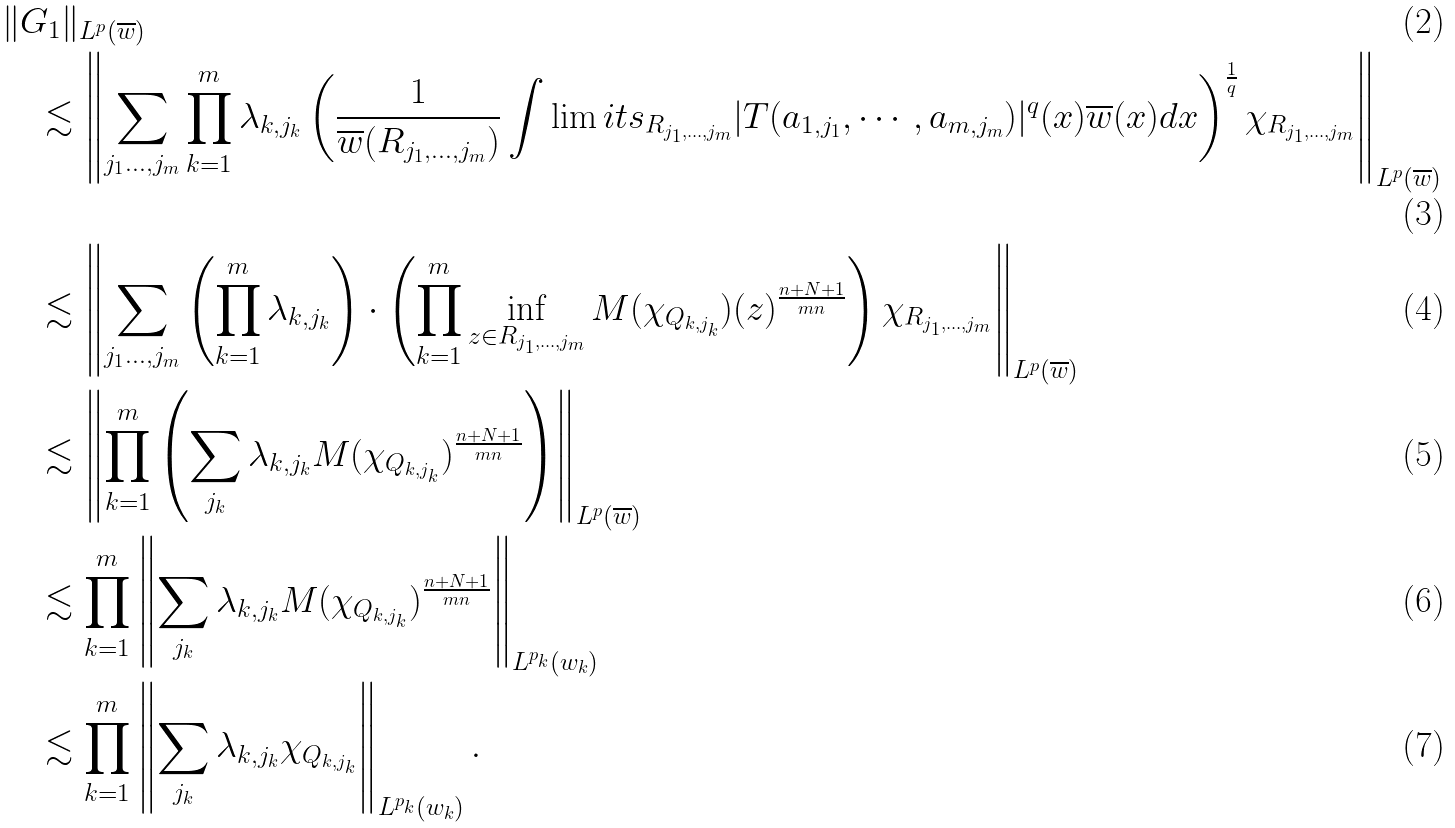<formula> <loc_0><loc_0><loc_500><loc_500>& \| G _ { 1 } \| _ { L ^ { p } ( \overline { w } ) } \\ & \quad \lesssim \left \| \sum _ { j _ { 1 } \dots , j _ { m } } \prod _ { k = 1 } ^ { m } { \lambda _ { k , j _ { k } } } \left ( \frac { 1 } { \overline { w } ( R _ { j _ { 1 } , \dots , j _ { m } } ) } \int \lim i t s _ { R _ { j _ { 1 } , \dots , j _ { m } } } | T ( a _ { 1 , j _ { 1 } } , \cdots , a _ { m , j _ { m } } ) | ^ { q } ( x ) \overline { w } ( x ) d x \right ) ^ { \frac { 1 } { q } } \chi _ { R _ { j _ { 1 } , \dots , j _ { m } } } \right \| _ { L ^ { p } ( \overline { w } ) } \\ & \quad \lesssim \left \| \sum _ { j _ { 1 } \dots , j _ { m } } \left ( \prod _ { k = 1 } ^ { m } { \lambda _ { k , j _ { k } } } \right ) \cdot \left ( \prod _ { k = 1 } ^ { m } \inf _ { z \in R _ { j _ { 1 } , \dots , j _ { m } } } M ( \chi _ { Q _ { k , j _ { k } } } ) ( z ) ^ { \frac { n + N + 1 } { m n } } \right ) \chi _ { R _ { j _ { 1 } , \dots , j _ { m } } } \right \| _ { L ^ { p } ( \overline { w } ) } \\ & \quad \lesssim \left \| \prod _ { k = 1 } ^ { m } \left ( \sum _ { j _ { k } } { \lambda _ { k , j _ { k } } } M ( \chi _ { Q _ { k , j _ { k } } } ) ^ { \frac { n + N + 1 } { m n } } \right ) \right \| _ { L ^ { p } ( \overline { w } ) } \\ & \quad \lesssim \prod _ { k = 1 } ^ { m } \left \| \sum _ { j _ { k } } { \lambda _ { k , j _ { k } } } M ( \chi _ { Q _ { k , j _ { k } } } ) ^ { \frac { n + N + 1 } { m n } } \right \| _ { L ^ { p _ { k } } ( w _ { k } ) } \\ & \quad \lesssim \prod _ { k = 1 } ^ { m } \left \| \sum _ { j _ { k } } { \lambda _ { k , j _ { k } } } \chi _ { Q _ { k , j _ { k } } } \right \| _ { L ^ { p _ { k } } ( w _ { k } ) } .</formula> 